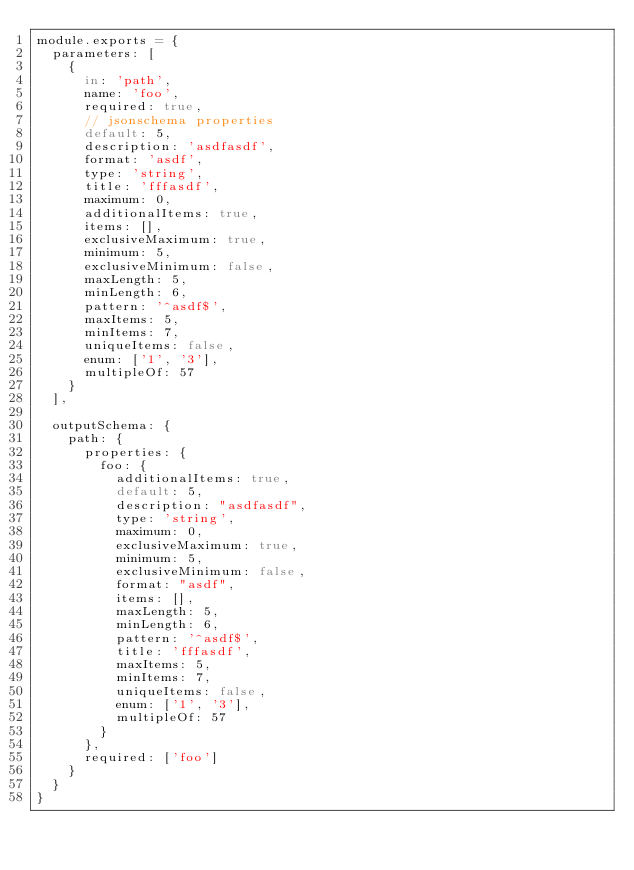Convert code to text. <code><loc_0><loc_0><loc_500><loc_500><_JavaScript_>module.exports = {
  parameters: [
    {
      in: 'path',
      name: 'foo',
      required: true,
      // jsonschema properties
      default: 5,
      description: 'asdfasdf',
      format: 'asdf',
      type: 'string',
      title: 'fffasdf',
      maximum: 0,
      additionalItems: true,
      items: [],
      exclusiveMaximum: true,
      minimum: 5,
      exclusiveMinimum: false,
      maxLength: 5,
      minLength: 6,
      pattern: '^asdf$',
      maxItems: 5,
      minItems: 7,
      uniqueItems: false,
      enum: ['1', '3'],
      multipleOf: 57
    }
  ],

  outputSchema: {
    path: {
      properties: {
        foo: {
          additionalItems: true,
          default: 5,
          description: "asdfasdf",
          type: 'string',
          maximum: 0,
          exclusiveMaximum: true,
          minimum: 5,
          exclusiveMinimum: false,
          format: "asdf",
          items: [],
          maxLength: 5,
          minLength: 6,
          pattern: '^asdf$',
          title: 'fffasdf',
          maxItems: 5,
          minItems: 7,
          uniqueItems: false,
          enum: ['1', '3'],
          multipleOf: 57
        }
      },
      required: ['foo']
    }
  }
}
</code> 